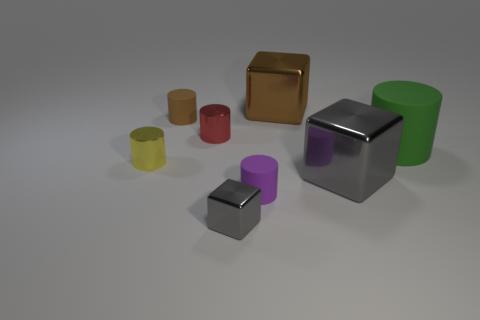Subtract all tiny purple cylinders. How many cylinders are left? 4 Subtract all yellow cylinders. How many cylinders are left? 4 Subtract all cyan cylinders. Subtract all purple blocks. How many cylinders are left? 5 Add 2 red things. How many objects exist? 10 Subtract all cubes. How many objects are left? 5 Subtract all small yellow cylinders. Subtract all tiny brown objects. How many objects are left? 6 Add 6 gray shiny objects. How many gray shiny objects are left? 8 Add 2 blue objects. How many blue objects exist? 2 Subtract 1 purple cylinders. How many objects are left? 7 